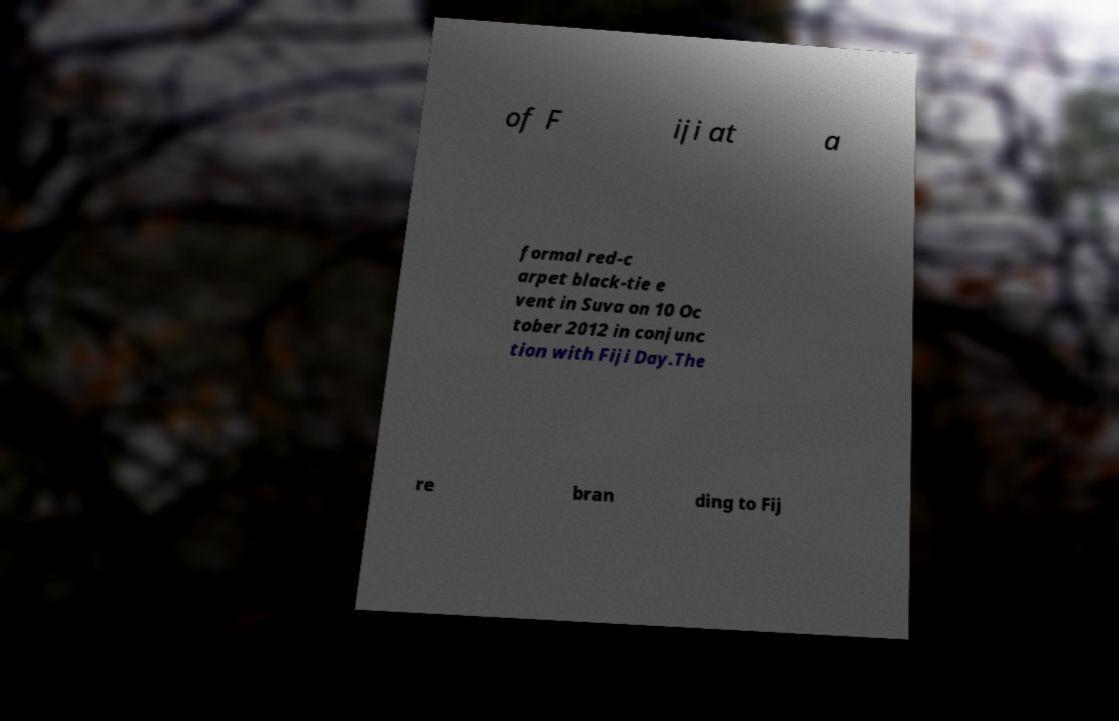I need the written content from this picture converted into text. Can you do that? of F iji at a formal red-c arpet black-tie e vent in Suva on 10 Oc tober 2012 in conjunc tion with Fiji Day.The re bran ding to Fij 